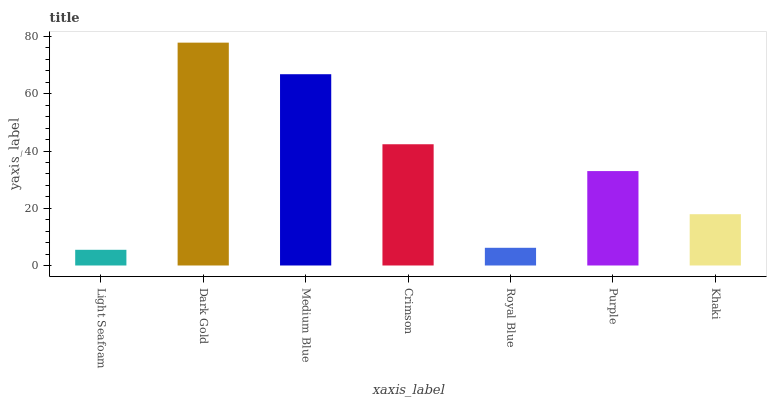Is Medium Blue the minimum?
Answer yes or no. No. Is Medium Blue the maximum?
Answer yes or no. No. Is Dark Gold greater than Medium Blue?
Answer yes or no. Yes. Is Medium Blue less than Dark Gold?
Answer yes or no. Yes. Is Medium Blue greater than Dark Gold?
Answer yes or no. No. Is Dark Gold less than Medium Blue?
Answer yes or no. No. Is Purple the high median?
Answer yes or no. Yes. Is Purple the low median?
Answer yes or no. Yes. Is Crimson the high median?
Answer yes or no. No. Is Crimson the low median?
Answer yes or no. No. 